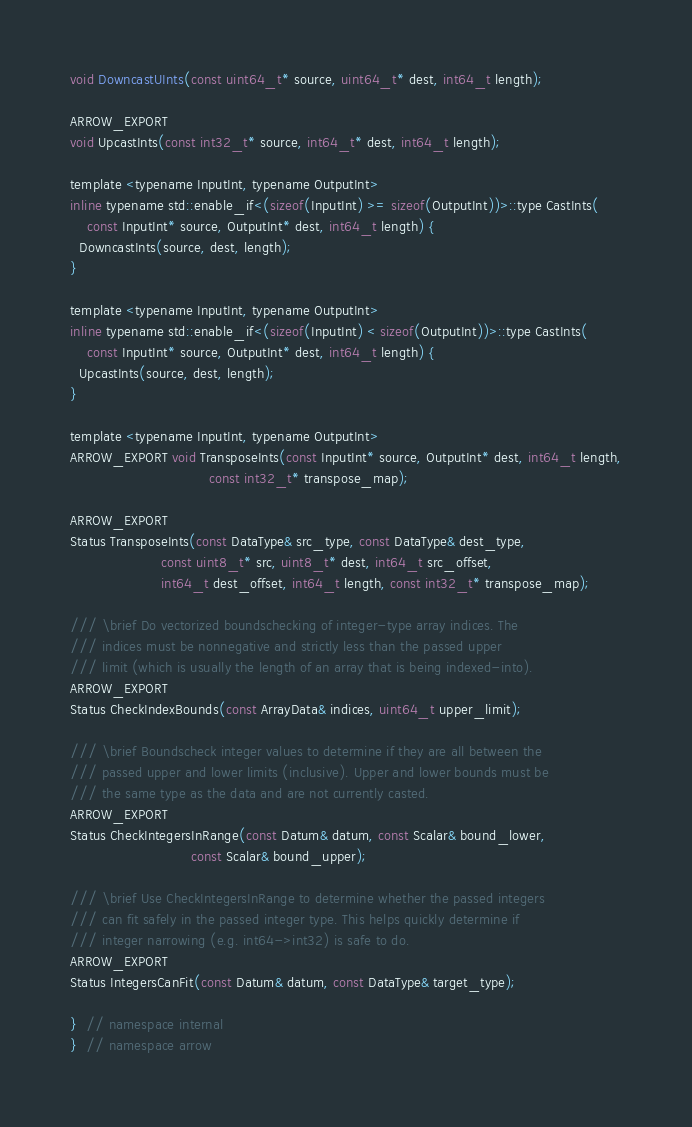Convert code to text. <code><loc_0><loc_0><loc_500><loc_500><_C_>void DowncastUInts(const uint64_t* source, uint64_t* dest, int64_t length);

ARROW_EXPORT
void UpcastInts(const int32_t* source, int64_t* dest, int64_t length);

template <typename InputInt, typename OutputInt>
inline typename std::enable_if<(sizeof(InputInt) >= sizeof(OutputInt))>::type CastInts(
    const InputInt* source, OutputInt* dest, int64_t length) {
  DowncastInts(source, dest, length);
}

template <typename InputInt, typename OutputInt>
inline typename std::enable_if<(sizeof(InputInt) < sizeof(OutputInt))>::type CastInts(
    const InputInt* source, OutputInt* dest, int64_t length) {
  UpcastInts(source, dest, length);
}

template <typename InputInt, typename OutputInt>
ARROW_EXPORT void TransposeInts(const InputInt* source, OutputInt* dest, int64_t length,
                                const int32_t* transpose_map);

ARROW_EXPORT
Status TransposeInts(const DataType& src_type, const DataType& dest_type,
                     const uint8_t* src, uint8_t* dest, int64_t src_offset,
                     int64_t dest_offset, int64_t length, const int32_t* transpose_map);

/// \brief Do vectorized boundschecking of integer-type array indices. The
/// indices must be nonnegative and strictly less than the passed upper
/// limit (which is usually the length of an array that is being indexed-into).
ARROW_EXPORT
Status CheckIndexBounds(const ArrayData& indices, uint64_t upper_limit);

/// \brief Boundscheck integer values to determine if they are all between the
/// passed upper and lower limits (inclusive). Upper and lower bounds must be
/// the same type as the data and are not currently casted.
ARROW_EXPORT
Status CheckIntegersInRange(const Datum& datum, const Scalar& bound_lower,
                            const Scalar& bound_upper);

/// \brief Use CheckIntegersInRange to determine whether the passed integers
/// can fit safely in the passed integer type. This helps quickly determine if
/// integer narrowing (e.g. int64->int32) is safe to do.
ARROW_EXPORT
Status IntegersCanFit(const Datum& datum, const DataType& target_type);

}  // namespace internal
}  // namespace arrow
</code> 